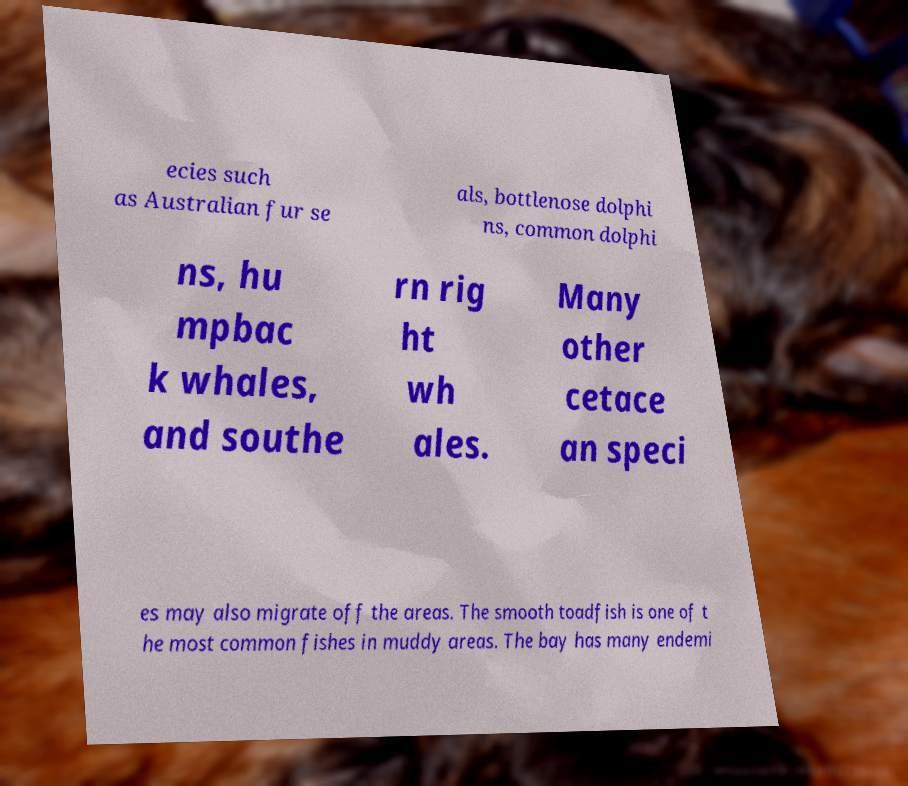Can you read and provide the text displayed in the image?This photo seems to have some interesting text. Can you extract and type it out for me? ecies such as Australian fur se als, bottlenose dolphi ns, common dolphi ns, hu mpbac k whales, and southe rn rig ht wh ales. Many other cetace an speci es may also migrate off the areas. The smooth toadfish is one of t he most common fishes in muddy areas. The bay has many endemi 